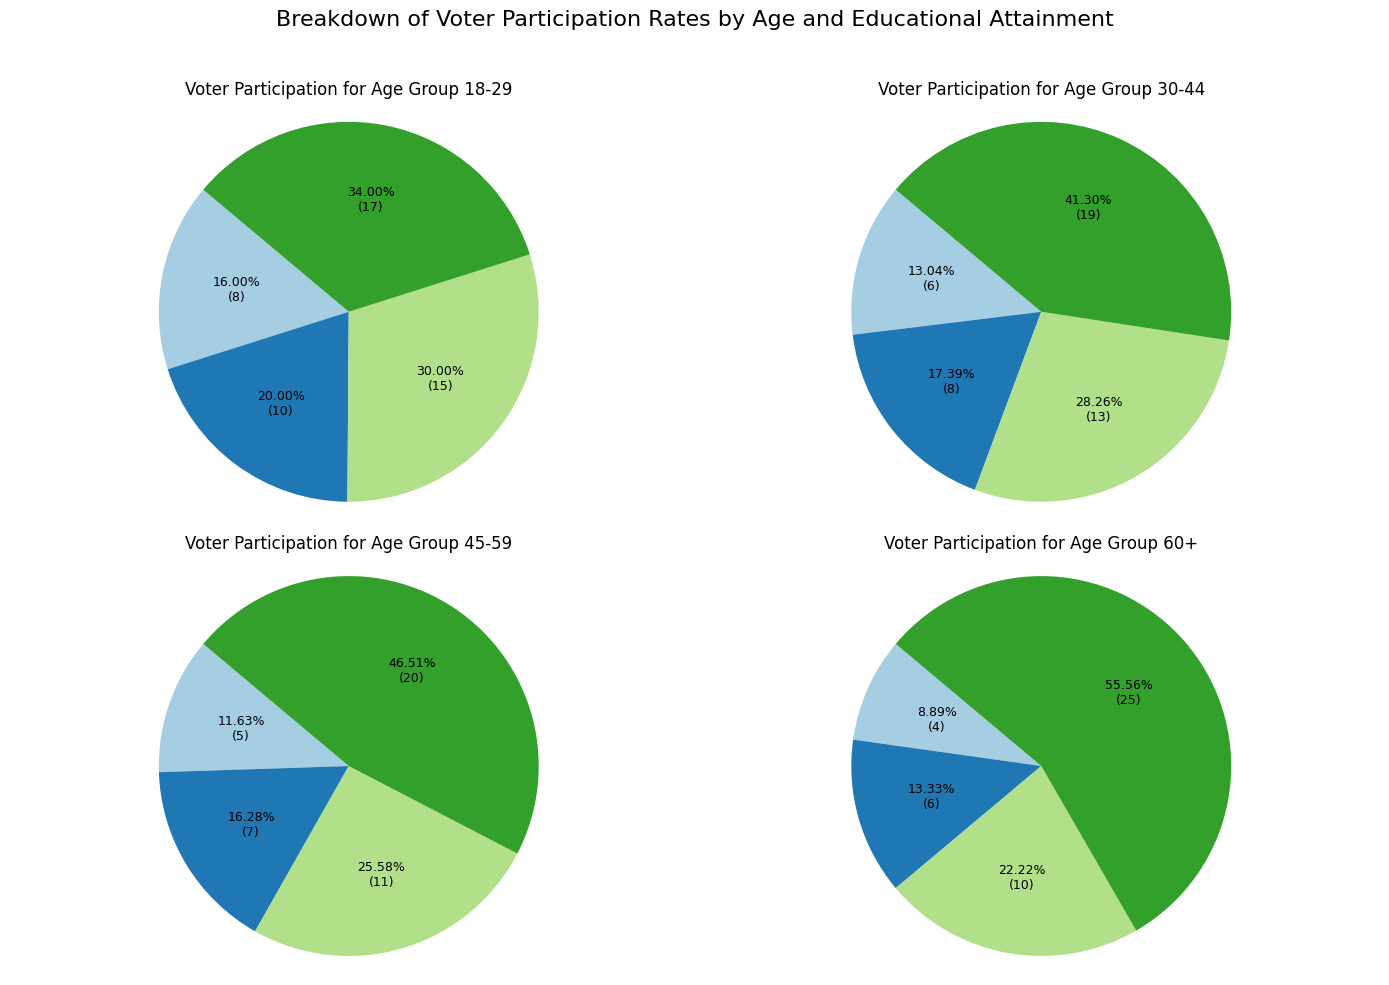What's the largest educational attainment category for the 60+ age group? By looking at the pie chart for the 60+ age group, observe which educational attainment section is the largest. The "College Graduate" section is the most substantial slice.
Answer: College Graduate Which age group has the smallest percentage of voters with no high school diploma? Compare the "No High School Diploma" segments across all age groups. The 60+ group has the smallest slice for this category.
Answer: 60+ Does the age group 18-29 or 30-44 have a higher participation rate for some college education? Compare the "Some College" slices between the 18-29 and 30-44 age groups. The 18-29 group has a larger slice for "Some College".
Answer: 18-29 What's the sum of voter participation percentages for high school graduates and college graduates in the 45-59 age group? Add the "High School Graduate" and "College Graduate" percentages for the 45-59 age group: 7% (High School) + 20% (College) = 27%.
Answer: 27% In which age group is the difference between high school graduates and some college the smallest? Calculate the difference between "High School Graduate" and "Some College" for each age group. The differences are: 18-29 (5%), 30-44 (5%), 45-59 (4%), 60+ (4%). The differences are smallest for the 45-59 and 60+ groups, each with a difference of 4%.
Answer: 45-59 and 60+ Which educational attainment category shows a consistent increase in voter participation from the youngest to the oldest age group? Track the slices of each educational attainment category from the youngest to the oldest age group. The "College Graduate" category shows a consistent increase: 17%, 19%, 20%, 25%.
Answer: College Graduate How does the participation of voters with some college education in the 30-44 age group compare to those in the 60+ age group? Compare the "Some College" slices between the 30-44 and the 60+ age groups. The 30-44 group has a larger percentage (13%) compared to the 60+ group (10%).
Answer: 30-44 has higher participation What is the average voter participation rate for high school graduates across all age groups? Sum the percentages of "High School Graduate" for all age groups and divide by the number of age groups: (10% + 8% + 7% + 6%) = 31%; 31% / 4 = 7.75%.
Answer: 7.75% Which age group has the highest difference between the highest and lowest voter participation rates within its categories? Calculate the difference between the highest and lowest rates for each age group: 18-29 (17%-8% = 9%), 30-44 (19%-6% = 13%), 45-59 (20%-5% = 15%), 60+ (25%-4% = 21%). The 60+ group has the highest difference.
Answer: 60+ What is the second most common educational attainment for voters aged 18-29? Look at the pie chart for the 18-29 age group and identify the second-largest slice after the largest. The largest is "College Graduate" (17%), the second largest is "Some College" (15%).
Answer: Some College 